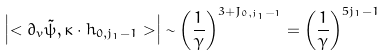Convert formula to latex. <formula><loc_0><loc_0><loc_500><loc_500>\left | < \partial _ { v } \tilde { \psi } , \kappa \cdot h _ { 0 , j _ { 1 } - 1 } > \right | \sim \left ( \frac { 1 } { \gamma } \right ) ^ { 3 + J _ { 0 , j _ { 1 } - 1 } } = \left ( \frac { 1 } { \gamma } \right ) ^ { 5 j _ { 1 } - 1 }</formula> 